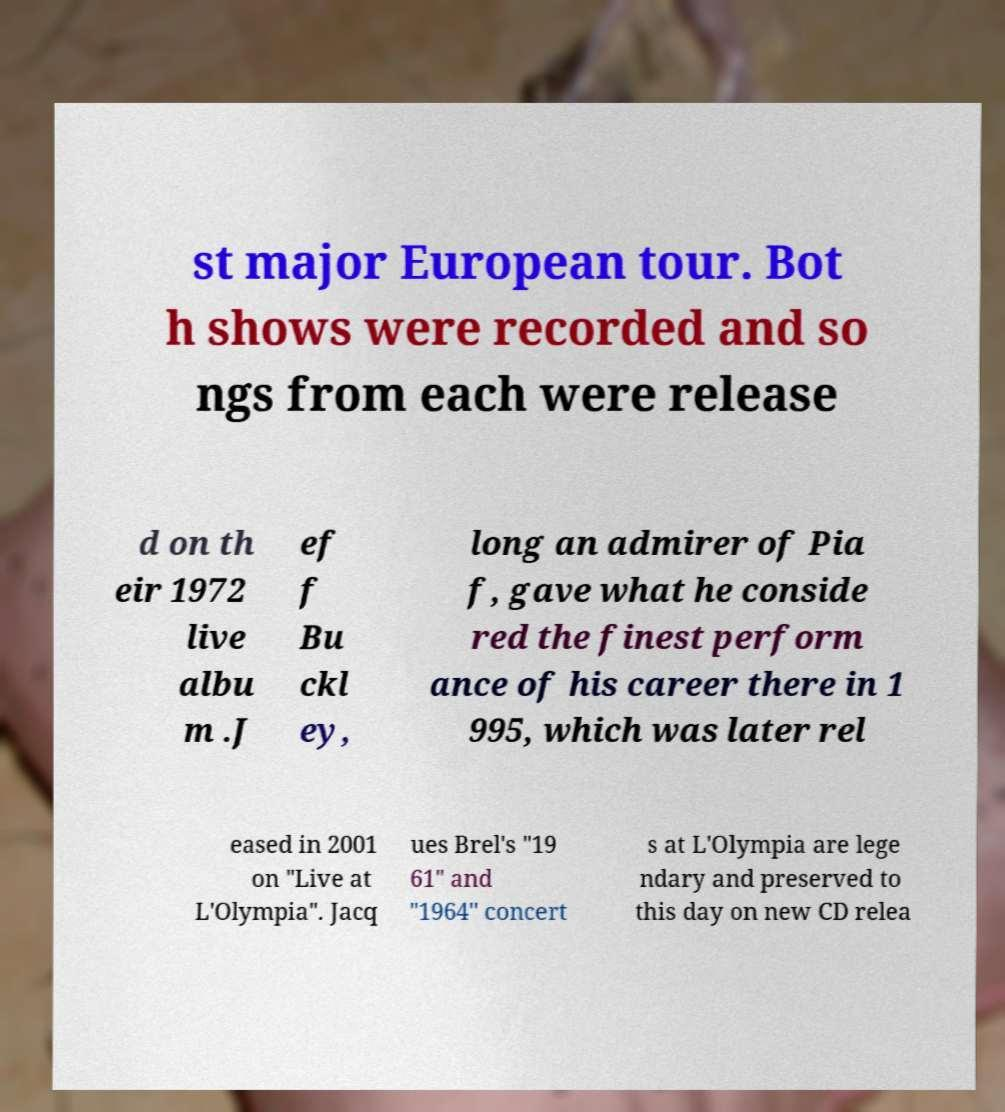There's text embedded in this image that I need extracted. Can you transcribe it verbatim? st major European tour. Bot h shows were recorded and so ngs from each were release d on th eir 1972 live albu m .J ef f Bu ckl ey, long an admirer of Pia f, gave what he conside red the finest perform ance of his career there in 1 995, which was later rel eased in 2001 on "Live at L'Olympia". Jacq ues Brel's "19 61" and "1964" concert s at L'Olympia are lege ndary and preserved to this day on new CD relea 